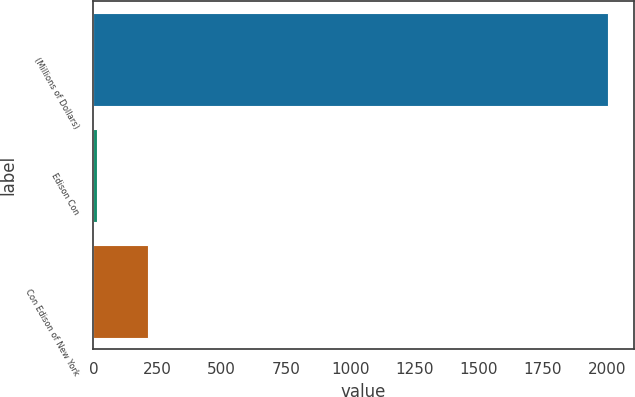Convert chart. <chart><loc_0><loc_0><loc_500><loc_500><bar_chart><fcel>(Millions of Dollars)<fcel>Edison Con<fcel>Con Edison of New York<nl><fcel>2005<fcel>14<fcel>213.1<nl></chart> 